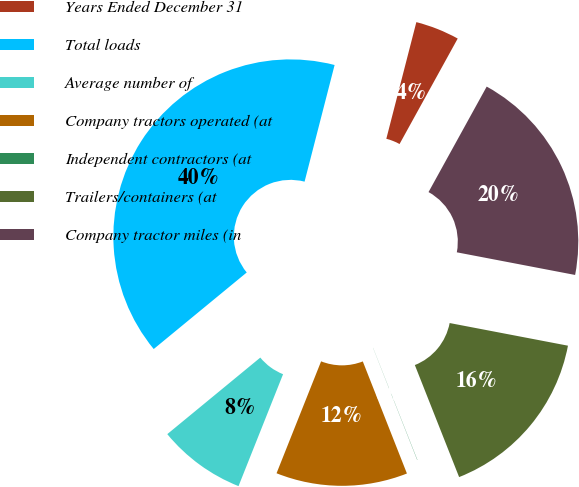Convert chart. <chart><loc_0><loc_0><loc_500><loc_500><pie_chart><fcel>Years Ended December 31<fcel>Total loads<fcel>Average number of<fcel>Company tractors operated (at<fcel>Independent contractors (at<fcel>Trailers/containers (at<fcel>Company tractor miles (in<nl><fcel>4.01%<fcel>39.97%<fcel>8.01%<fcel>12.0%<fcel>0.02%<fcel>16.0%<fcel>19.99%<nl></chart> 